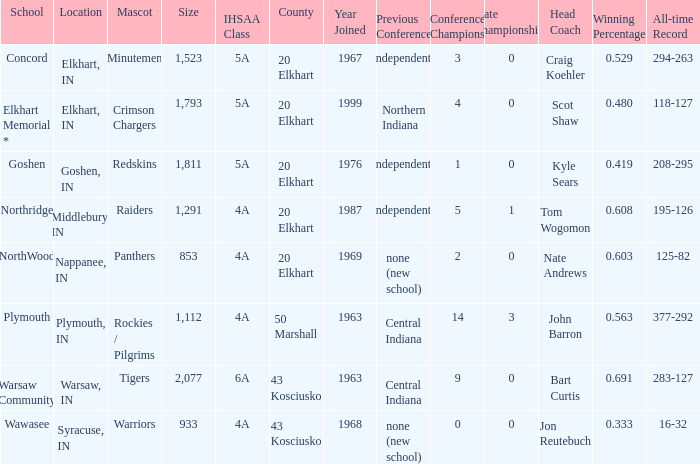What is the size of the team that was previously from Central Indiana conference, and is in IHSSA Class 4a? 1112.0. 